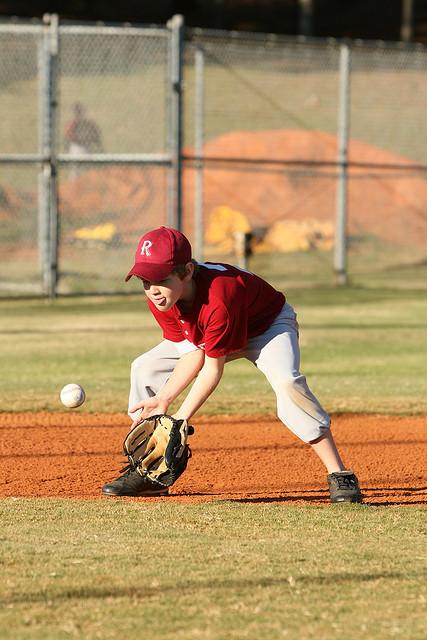What is on his hand?
Keep it brief. Glove. About how old is the child in the photo?
Concise answer only. 10. Will the boy catch the ball?
Give a very brief answer. Yes. 